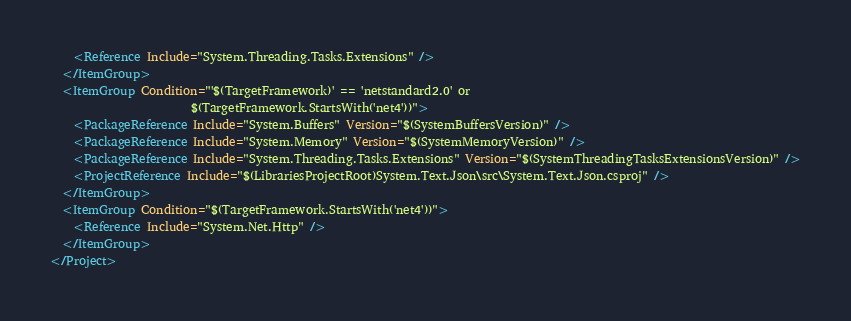Convert code to text. <code><loc_0><loc_0><loc_500><loc_500><_XML_>    <Reference Include="System.Threading.Tasks.Extensions" />
  </ItemGroup>
  <ItemGroup Condition="'$(TargetFramework)' == 'netstandard2.0' or
                        $(TargetFramework.StartsWith('net4'))">
    <PackageReference Include="System.Buffers" Version="$(SystemBuffersVersion)" />
    <PackageReference Include="System.Memory" Version="$(SystemMemoryVersion)" />
    <PackageReference Include="System.Threading.Tasks.Extensions" Version="$(SystemThreadingTasksExtensionsVersion)" />
    <ProjectReference Include="$(LibrariesProjectRoot)System.Text.Json\src\System.Text.Json.csproj" />
  </ItemGroup>
  <ItemGroup Condition="$(TargetFramework.StartsWith('net4'))">
    <Reference Include="System.Net.Http" />
  </ItemGroup>
</Project>
</code> 